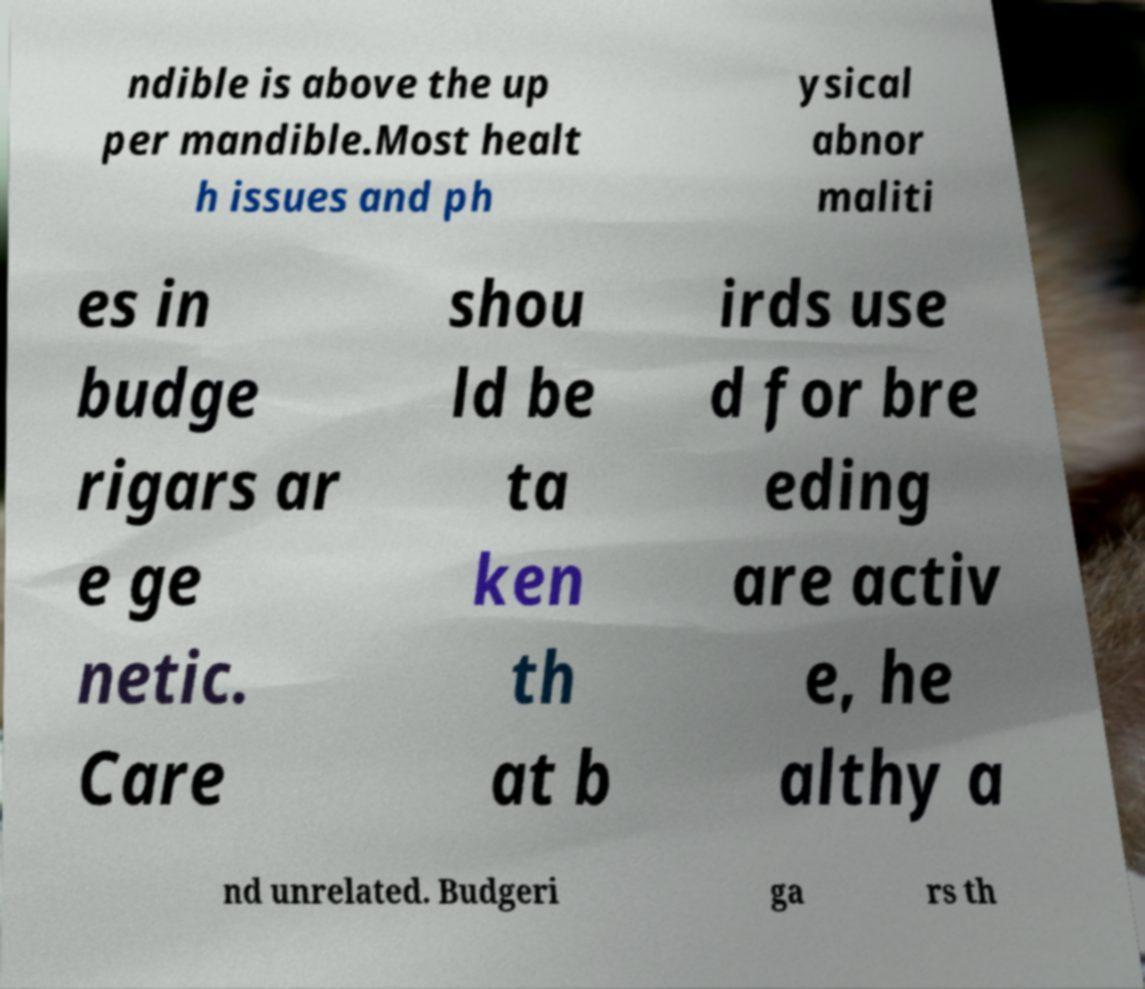I need the written content from this picture converted into text. Can you do that? ndible is above the up per mandible.Most healt h issues and ph ysical abnor maliti es in budge rigars ar e ge netic. Care shou ld be ta ken th at b irds use d for bre eding are activ e, he althy a nd unrelated. Budgeri ga rs th 